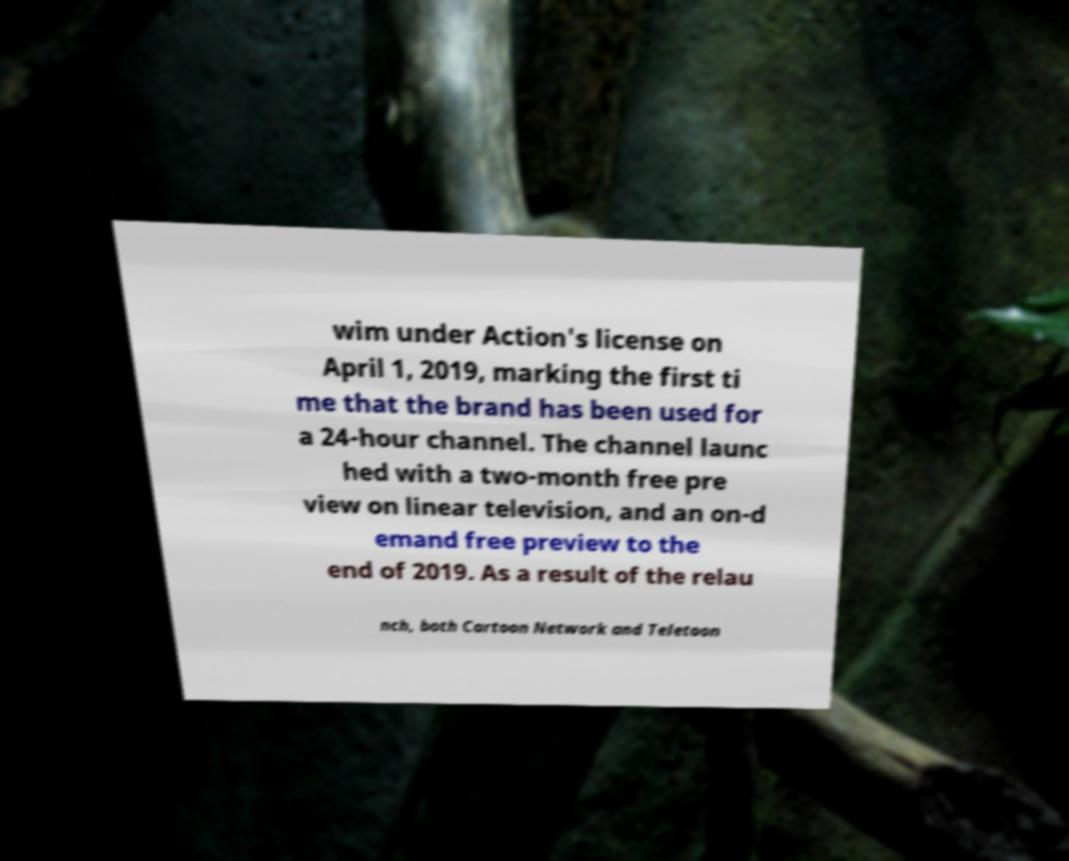Please read and relay the text visible in this image. What does it say? wim under Action's license on April 1, 2019, marking the first ti me that the brand has been used for a 24-hour channel. The channel launc hed with a two-month free pre view on linear television, and an on-d emand free preview to the end of 2019. As a result of the relau nch, both Cartoon Network and Teletoon 